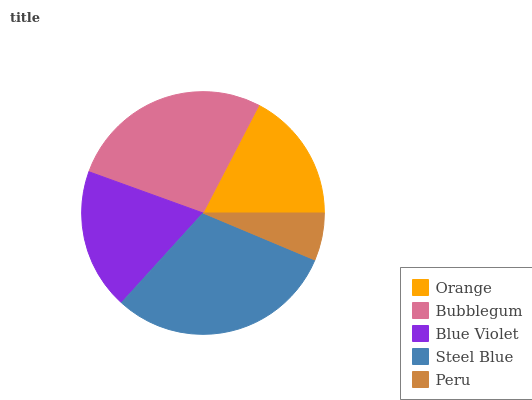Is Peru the minimum?
Answer yes or no. Yes. Is Steel Blue the maximum?
Answer yes or no. Yes. Is Bubblegum the minimum?
Answer yes or no. No. Is Bubblegum the maximum?
Answer yes or no. No. Is Bubblegum greater than Orange?
Answer yes or no. Yes. Is Orange less than Bubblegum?
Answer yes or no. Yes. Is Orange greater than Bubblegum?
Answer yes or no. No. Is Bubblegum less than Orange?
Answer yes or no. No. Is Blue Violet the high median?
Answer yes or no. Yes. Is Blue Violet the low median?
Answer yes or no. Yes. Is Steel Blue the high median?
Answer yes or no. No. Is Orange the low median?
Answer yes or no. No. 